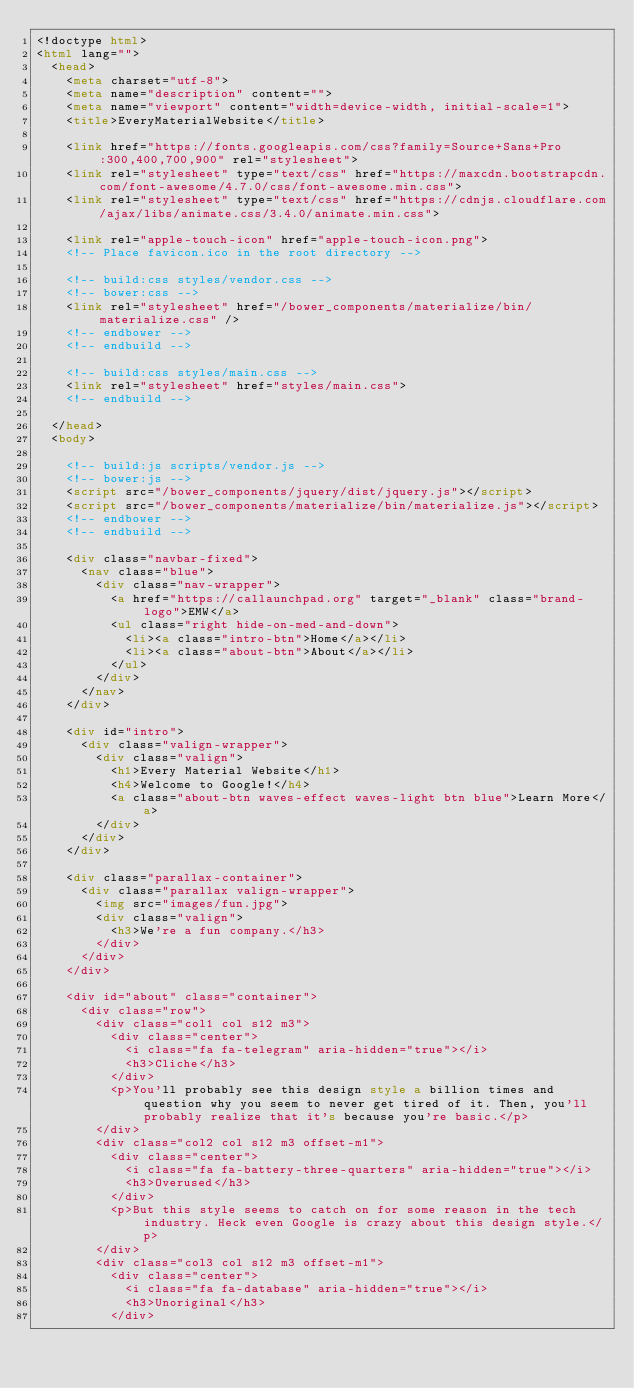<code> <loc_0><loc_0><loc_500><loc_500><_HTML_><!doctype html>
<html lang="">
  <head>
    <meta charset="utf-8">
    <meta name="description" content="">
    <meta name="viewport" content="width=device-width, initial-scale=1">
    <title>EveryMaterialWebsite</title>

    <link href="https://fonts.googleapis.com/css?family=Source+Sans+Pro:300,400,700,900" rel="stylesheet">
    <link rel="stylesheet" type="text/css" href="https://maxcdn.bootstrapcdn.com/font-awesome/4.7.0/css/font-awesome.min.css">
    <link rel="stylesheet" type="text/css" href="https://cdnjs.cloudflare.com/ajax/libs/animate.css/3.4.0/animate.min.css">

    <link rel="apple-touch-icon" href="apple-touch-icon.png">
    <!-- Place favicon.ico in the root directory -->

    <!-- build:css styles/vendor.css -->
    <!-- bower:css -->
    <link rel="stylesheet" href="/bower_components/materialize/bin/materialize.css" />
    <!-- endbower -->
    <!-- endbuild -->

    <!-- build:css styles/main.css -->
    <link rel="stylesheet" href="styles/main.css">
    <!-- endbuild -->
    
  </head>
  <body>

    <!-- build:js scripts/vendor.js -->
    <!-- bower:js -->
    <script src="/bower_components/jquery/dist/jquery.js"></script>
    <script src="/bower_components/materialize/bin/materialize.js"></script>
    <!-- endbower -->
    <!-- endbuild -->

    <div class="navbar-fixed">
      <nav class="blue">
        <div class="nav-wrapper">
          <a href="https://callaunchpad.org" target="_blank" class="brand-logo">EMW</a>
          <ul class="right hide-on-med-and-down">
            <li><a class="intro-btn">Home</a></li>
            <li><a class="about-btn">About</a></li>
          </ul>
        </div>
      </nav>
    </div>

    <div id="intro">
      <div class="valign-wrapper">
        <div class="valign">
          <h1>Every Material Website</h1>
          <h4>Welcome to Google!</h4>
          <a class="about-btn waves-effect waves-light btn blue">Learn More</a>
        </div>
      </div>
    </div>

    <div class="parallax-container">
      <div class="parallax valign-wrapper">
        <img src="images/fun.jpg">
        <div class="valign">
          <h3>We're a fun company.</h3>
        </div>
      </div>
    </div>

    <div id="about" class="container">
      <div class="row">
        <div class="col1 col s12 m3">
          <div class="center">
            <i class="fa fa-telegram" aria-hidden="true"></i>
            <h3>Cliche</h3>
          </div>
          <p>You'll probably see this design style a billion times and question why you seem to never get tired of it. Then, you'll probably realize that it's because you're basic.</p>
        </div>
        <div class="col2 col s12 m3 offset-m1">
          <div class="center">
            <i class="fa fa-battery-three-quarters" aria-hidden="true"></i>
            <h3>Overused</h3>
          </div>
          <p>But this style seems to catch on for some reason in the tech industry. Heck even Google is crazy about this design style.</p>
        </div>
        <div class="col3 col s12 m3 offset-m1">
          <div class="center">
            <i class="fa fa-database" aria-hidden="true"></i>
            <h3>Unoriginal</h3>
          </div></code> 